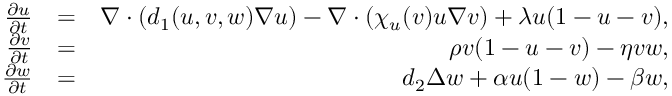Convert formula to latex. <formula><loc_0><loc_0><loc_500><loc_500>\begin{array} { r l r } { \frac { \partial u } { \partial t } } & { = } & { \nabla \cdot ( d _ { 1 } ( u , v , w ) \nabla u ) - \nabla \cdot ( \chi _ { u } ( v ) u \nabla v ) + \lambda u ( 1 - u - v ) , } \\ { \frac { \partial v } { \partial t } } & { = } & { \rho v ( 1 - u - v ) - \eta v w , } \\ { \frac { \partial w } { \partial t } } & { = } & { d _ { 2 } \Delta w + \alpha u ( 1 - w ) - \beta w , } \end{array}</formula> 